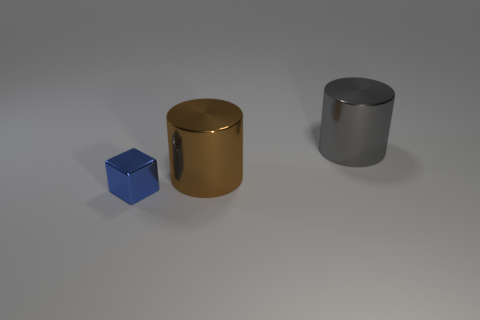What number of rubber things are large brown cylinders or gray objects?
Keep it short and to the point. 0. Is the number of small blue objects that are on the left side of the big gray metallic object greater than the number of brown rubber balls?
Offer a terse response. Yes. How many other objects are the same material as the large gray cylinder?
Provide a succinct answer. 2. What number of large objects are either brown matte cylinders or cylinders?
Your answer should be very brief. 2. Do the big brown cylinder and the small thing have the same material?
Provide a succinct answer. Yes. There is a metallic cylinder to the left of the gray metallic cylinder; what number of shiny things are to the left of it?
Your response must be concise. 1. Is there another object that has the same shape as the brown metallic thing?
Keep it short and to the point. Yes. There is a large thing that is in front of the large gray cylinder; is it the same shape as the shiny object on the right side of the brown shiny cylinder?
Make the answer very short. Yes. Are there any objects that have the same size as the gray cylinder?
Provide a succinct answer. Yes. What is the material of the gray thing?
Offer a terse response. Metal. 